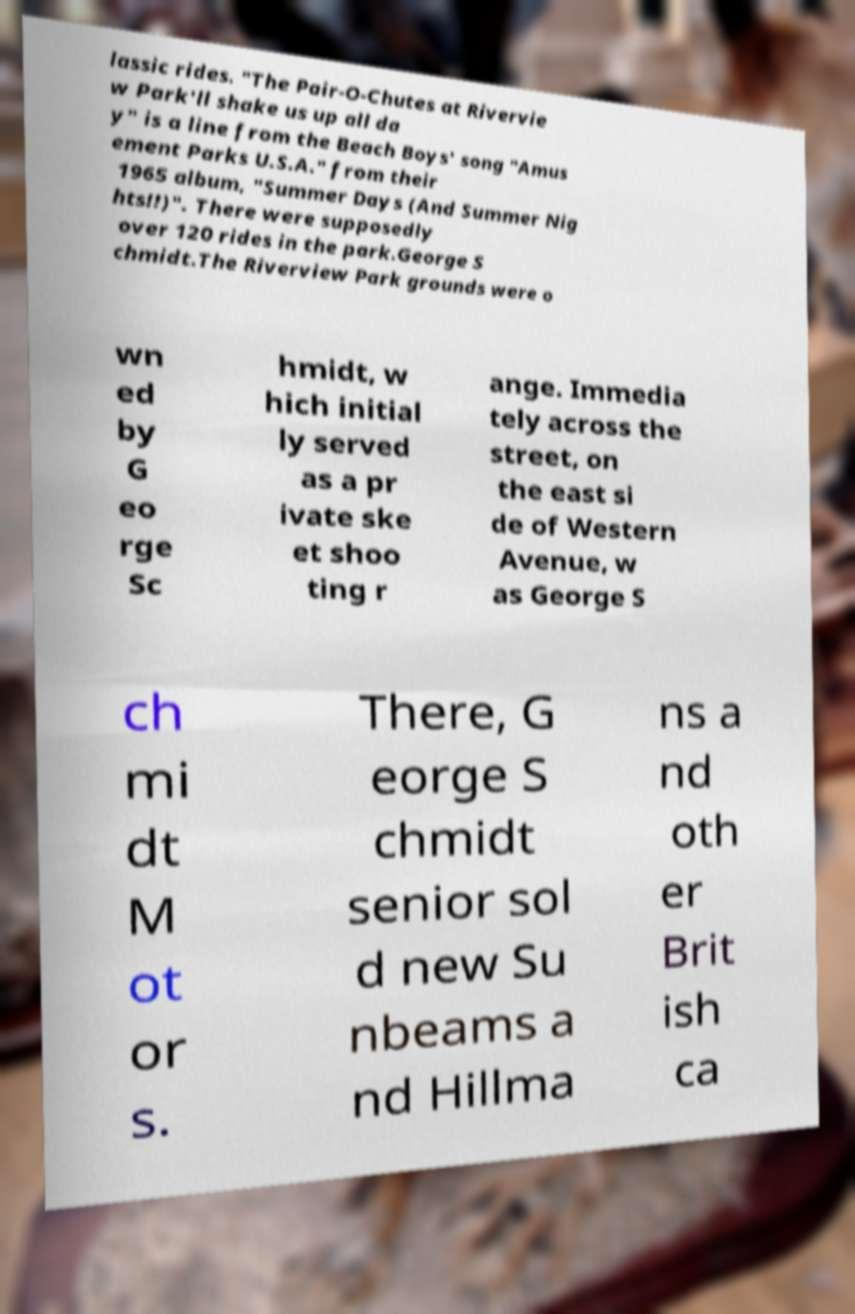Please identify and transcribe the text found in this image. lassic rides. "The Pair-O-Chutes at Rivervie w Park'll shake us up all da y" is a line from the Beach Boys' song "Amus ement Parks U.S.A." from their 1965 album, "Summer Days (And Summer Nig hts!!)". There were supposedly over 120 rides in the park.George S chmidt.The Riverview Park grounds were o wn ed by G eo rge Sc hmidt, w hich initial ly served as a pr ivate ske et shoo ting r ange. Immedia tely across the street, on the east si de of Western Avenue, w as George S ch mi dt M ot or s. There, G eorge S chmidt senior sol d new Su nbeams a nd Hillma ns a nd oth er Brit ish ca 